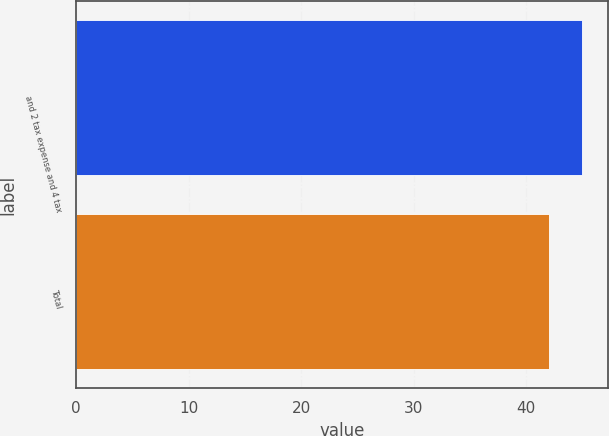Convert chart. <chart><loc_0><loc_0><loc_500><loc_500><bar_chart><fcel>and 2 tax expense and 4 tax<fcel>Total<nl><fcel>45<fcel>42<nl></chart> 